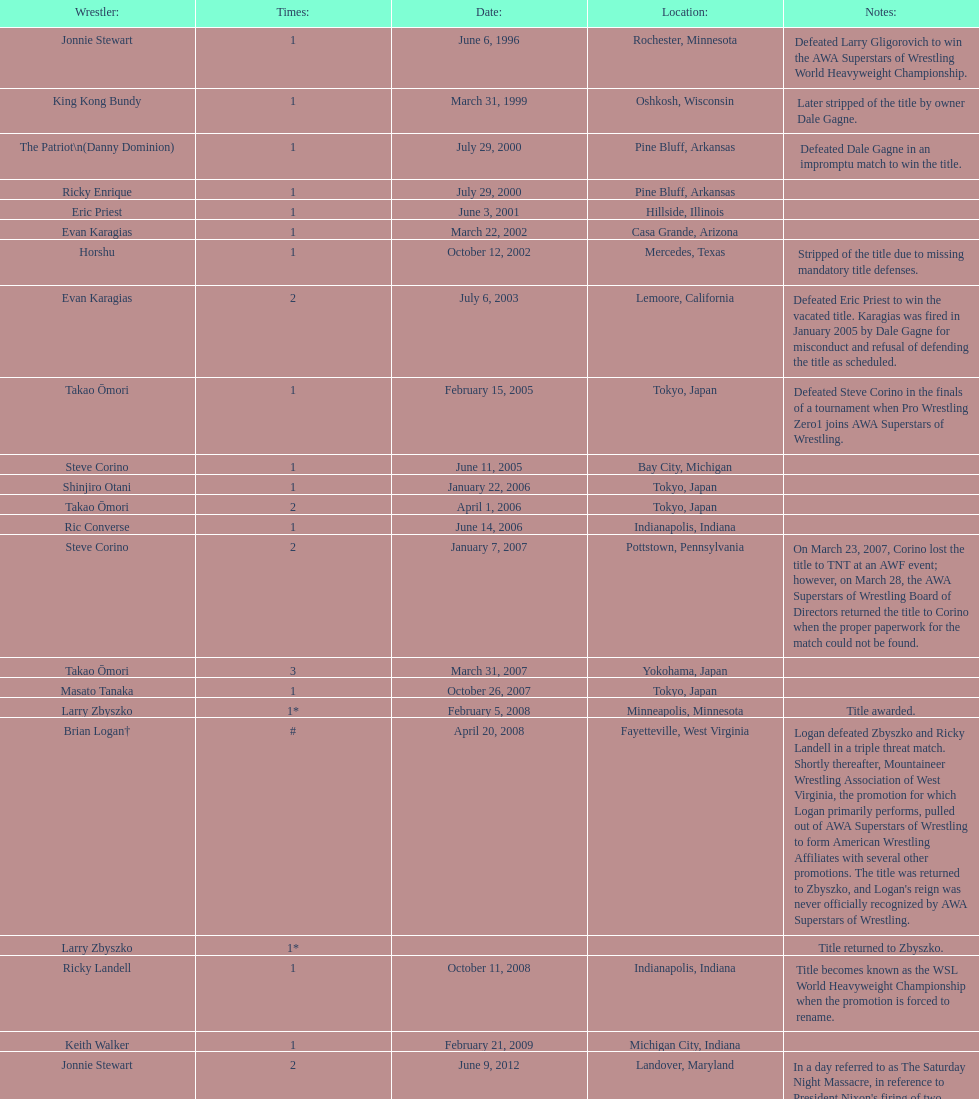When did steve corino obtain his first wsl crown? June 11, 2005. 